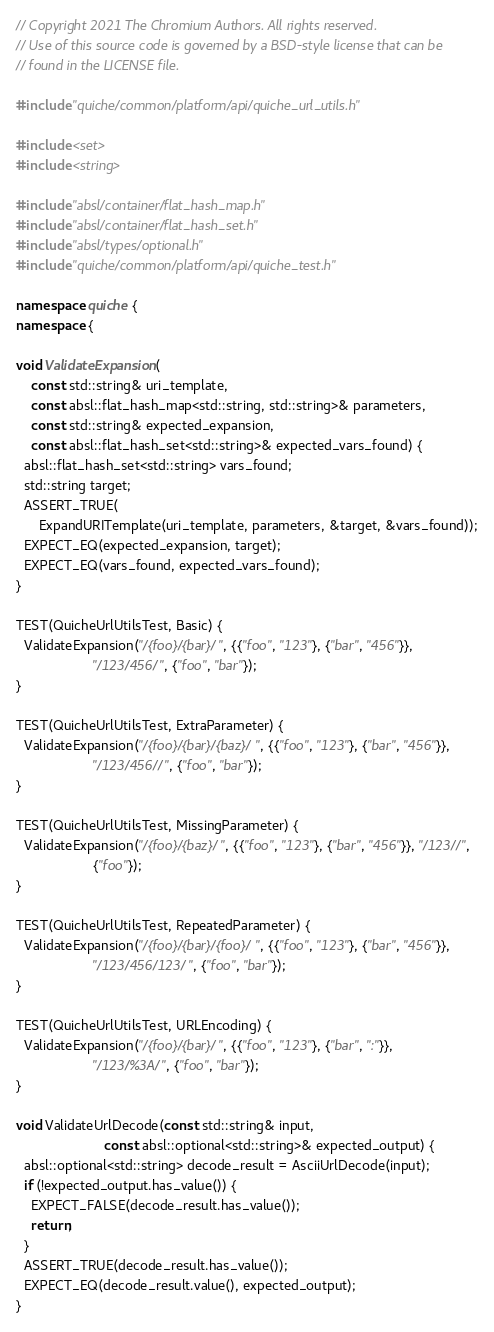<code> <loc_0><loc_0><loc_500><loc_500><_C++_>// Copyright 2021 The Chromium Authors. All rights reserved.
// Use of this source code is governed by a BSD-style license that can be
// found in the LICENSE file.

#include "quiche/common/platform/api/quiche_url_utils.h"

#include <set>
#include <string>

#include "absl/container/flat_hash_map.h"
#include "absl/container/flat_hash_set.h"
#include "absl/types/optional.h"
#include "quiche/common/platform/api/quiche_test.h"

namespace quiche {
namespace {

void ValidateExpansion(
    const std::string& uri_template,
    const absl::flat_hash_map<std::string, std::string>& parameters,
    const std::string& expected_expansion,
    const absl::flat_hash_set<std::string>& expected_vars_found) {
  absl::flat_hash_set<std::string> vars_found;
  std::string target;
  ASSERT_TRUE(
      ExpandURITemplate(uri_template, parameters, &target, &vars_found));
  EXPECT_EQ(expected_expansion, target);
  EXPECT_EQ(vars_found, expected_vars_found);
}

TEST(QuicheUrlUtilsTest, Basic) {
  ValidateExpansion("/{foo}/{bar}/", {{"foo", "123"}, {"bar", "456"}},
                    "/123/456/", {"foo", "bar"});
}

TEST(QuicheUrlUtilsTest, ExtraParameter) {
  ValidateExpansion("/{foo}/{bar}/{baz}/", {{"foo", "123"}, {"bar", "456"}},
                    "/123/456//", {"foo", "bar"});
}

TEST(QuicheUrlUtilsTest, MissingParameter) {
  ValidateExpansion("/{foo}/{baz}/", {{"foo", "123"}, {"bar", "456"}}, "/123//",
                    {"foo"});
}

TEST(QuicheUrlUtilsTest, RepeatedParameter) {
  ValidateExpansion("/{foo}/{bar}/{foo}/", {{"foo", "123"}, {"bar", "456"}},
                    "/123/456/123/", {"foo", "bar"});
}

TEST(QuicheUrlUtilsTest, URLEncoding) {
  ValidateExpansion("/{foo}/{bar}/", {{"foo", "123"}, {"bar", ":"}},
                    "/123/%3A/", {"foo", "bar"});
}

void ValidateUrlDecode(const std::string& input,
                       const absl::optional<std::string>& expected_output) {
  absl::optional<std::string> decode_result = AsciiUrlDecode(input);
  if (!expected_output.has_value()) {
    EXPECT_FALSE(decode_result.has_value());
    return;
  }
  ASSERT_TRUE(decode_result.has_value());
  EXPECT_EQ(decode_result.value(), expected_output);
}
</code> 